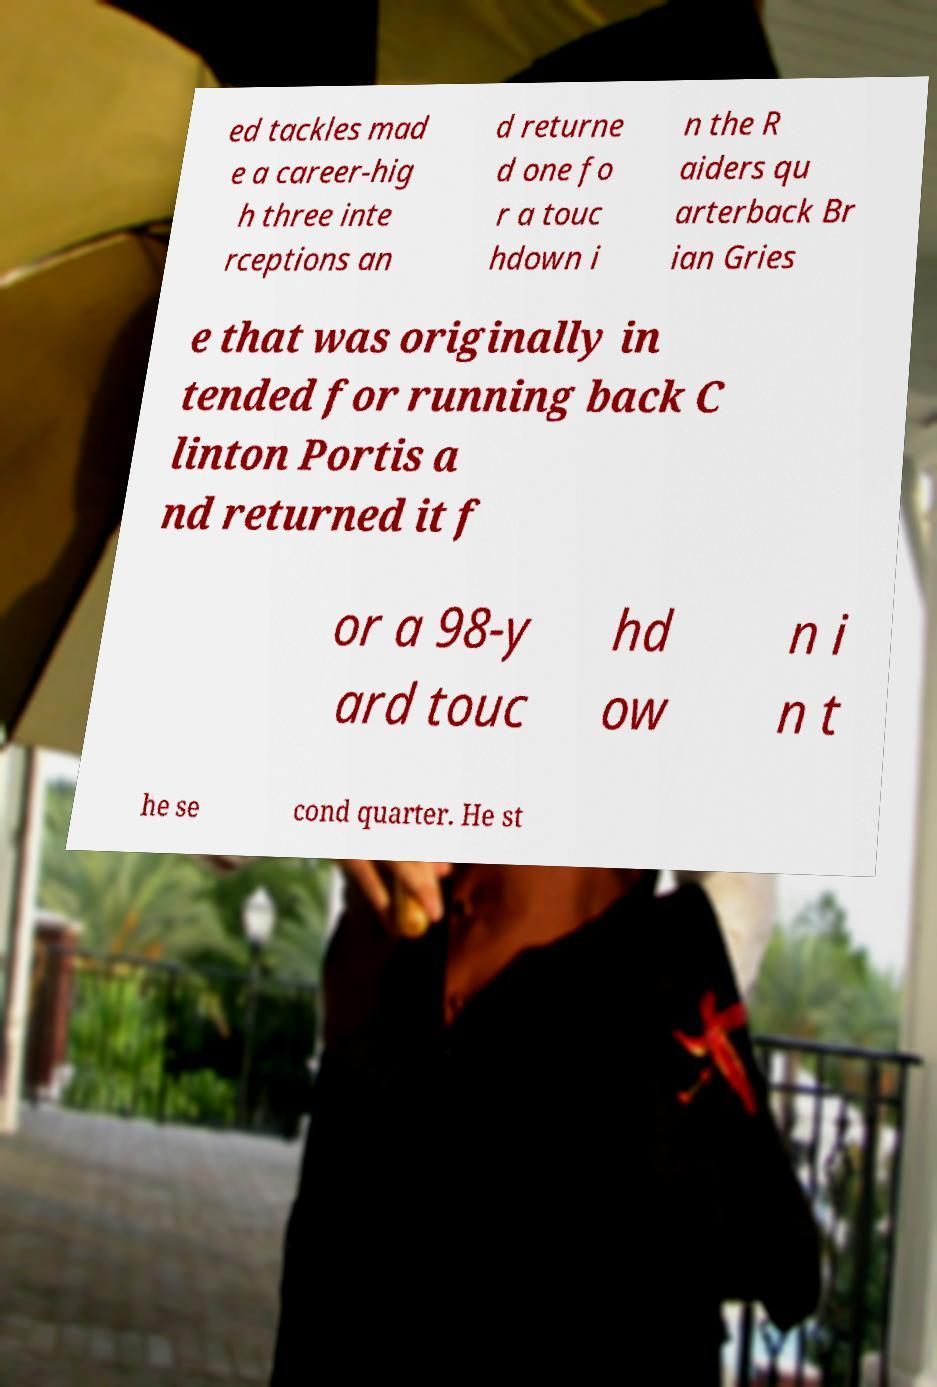Please identify and transcribe the text found in this image. ed tackles mad e a career-hig h three inte rceptions an d returne d one fo r a touc hdown i n the R aiders qu arterback Br ian Gries e that was originally in tended for running back C linton Portis a nd returned it f or a 98-y ard touc hd ow n i n t he se cond quarter. He st 